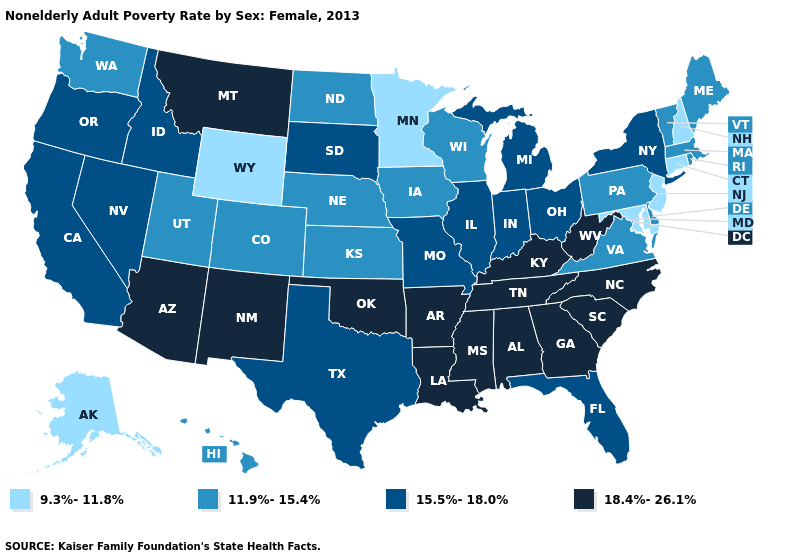What is the lowest value in the USA?
Be succinct. 9.3%-11.8%. Which states have the highest value in the USA?
Be succinct. Alabama, Arizona, Arkansas, Georgia, Kentucky, Louisiana, Mississippi, Montana, New Mexico, North Carolina, Oklahoma, South Carolina, Tennessee, West Virginia. Among the states that border New Jersey , does Delaware have the highest value?
Give a very brief answer. No. What is the highest value in states that border California?
Quick response, please. 18.4%-26.1%. What is the value of Hawaii?
Quick response, please. 11.9%-15.4%. What is the value of Ohio?
Concise answer only. 15.5%-18.0%. What is the highest value in states that border Kansas?
Keep it brief. 18.4%-26.1%. Name the states that have a value in the range 11.9%-15.4%?
Concise answer only. Colorado, Delaware, Hawaii, Iowa, Kansas, Maine, Massachusetts, Nebraska, North Dakota, Pennsylvania, Rhode Island, Utah, Vermont, Virginia, Washington, Wisconsin. Is the legend a continuous bar?
Give a very brief answer. No. Name the states that have a value in the range 9.3%-11.8%?
Give a very brief answer. Alaska, Connecticut, Maryland, Minnesota, New Hampshire, New Jersey, Wyoming. Which states have the lowest value in the USA?
Be succinct. Alaska, Connecticut, Maryland, Minnesota, New Hampshire, New Jersey, Wyoming. Does Wyoming have the highest value in the USA?
Be succinct. No. What is the highest value in the MidWest ?
Be succinct. 15.5%-18.0%. Among the states that border North Dakota , does Minnesota have the highest value?
Quick response, please. No. What is the highest value in the Northeast ?
Keep it brief. 15.5%-18.0%. 